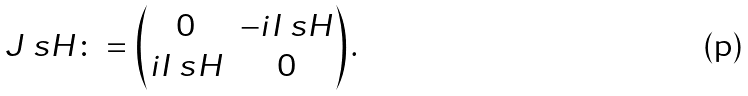<formula> <loc_0><loc_0><loc_500><loc_500>J _ { \ } s H \colon = \begin{pmatrix} 0 & - i I _ { \ } s H \\ i I _ { \ } s H & 0 \end{pmatrix} .</formula> 